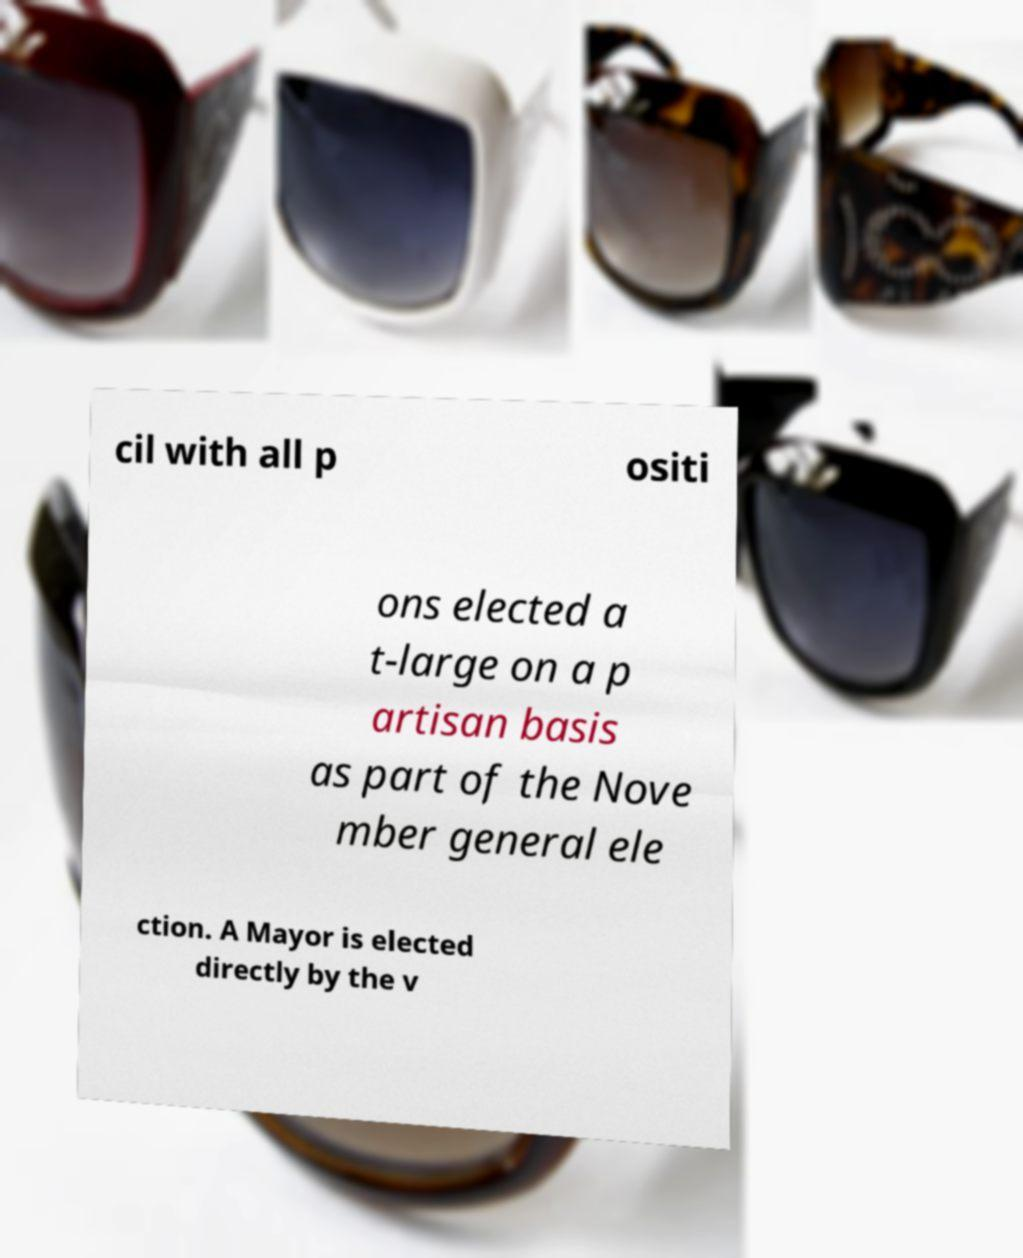I need the written content from this picture converted into text. Can you do that? cil with all p ositi ons elected a t-large on a p artisan basis as part of the Nove mber general ele ction. A Mayor is elected directly by the v 